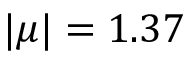<formula> <loc_0><loc_0><loc_500><loc_500>| \mu | = 1 . 3 7</formula> 